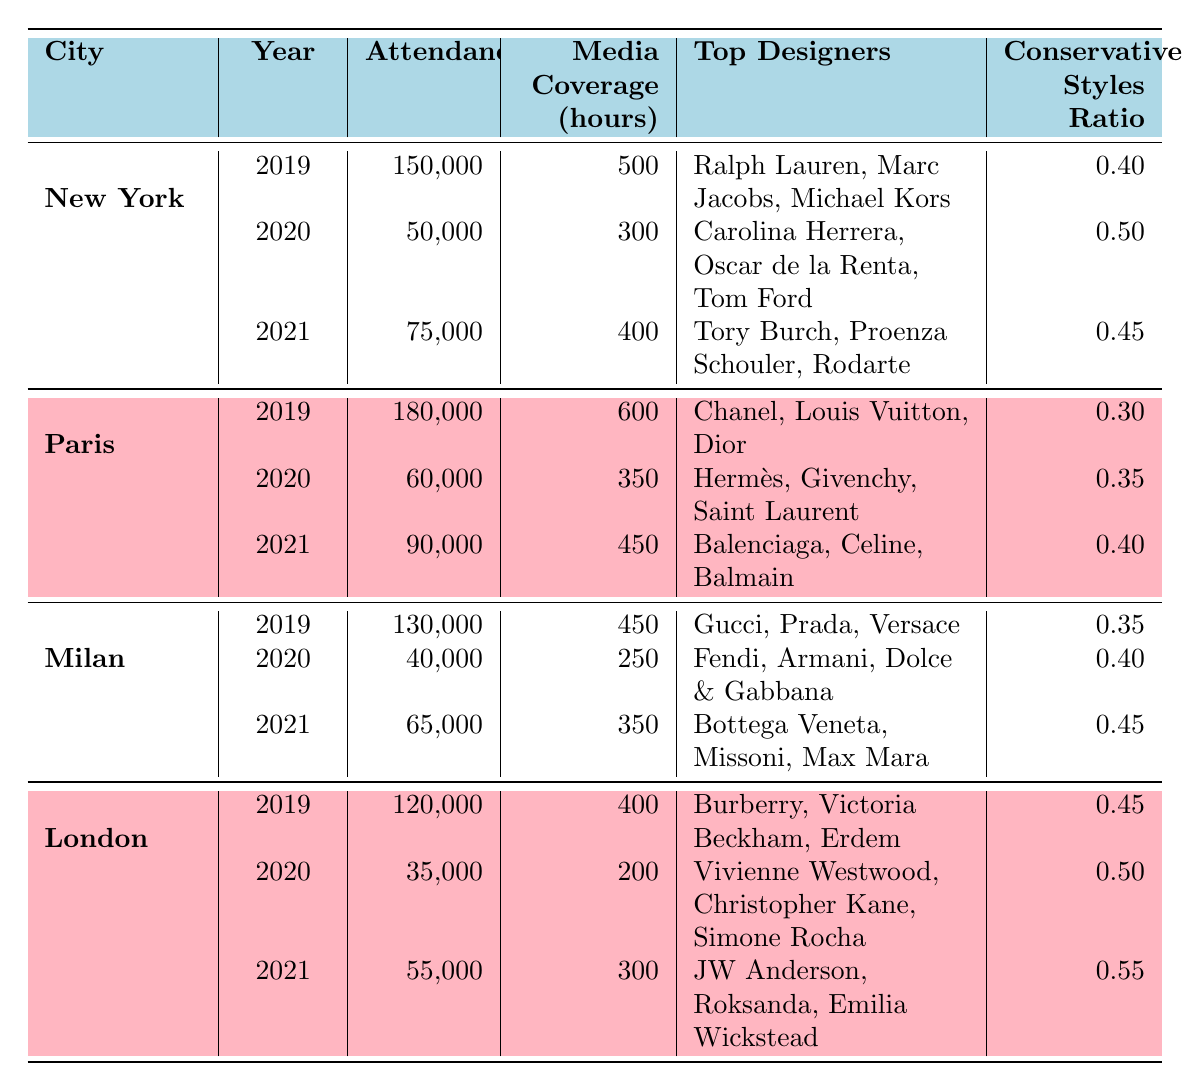What city had the highest attendance in 2019? The table shows the attendance for each city in 2019. New York had 150,000, Paris had 180,000, Milan had 130,000, and London had 120,000. The highest attendance is 180,000 in Paris.
Answer: Paris What was the media coverage in hours for Milan in 2021? For Milan in 2021, the table directly lists the media coverage as 350 hours.
Answer: 350 What was the ratio of conservative styles for London in 2020? The table states that the conservative styles ratio for London in 2020 is 0.50.
Answer: 0.50 Which city had the lowest media coverage in 2020, and what was the amount? The media coverage in 2020 for New York was 300 hours, Paris was 350 hours, Milan was 250 hours, and London was 200 hours. London had the lowest media coverage with 200 hours.
Answer: London, 200 What was the total attendance across all cities in 2019? Adding the attendance values for all cities in 2019 gives: 150,000 (New York) + 180,000 (Paris) + 130,000 (Milan) + 120,000 (London) = 580,000.
Answer: 580,000 Did fashion week attendance increase from 2020 to 2021 in all cities? New York’s attendance changed from 50,000 to 75,000 (increased), Paris's changed from 60,000 to 90,000 (increased), Milan changed from 40,000 to 65,000 (increased), and London changed from 35,000 to 55,000 (increased). Therefore, attendance increased in all cities.
Answer: Yes What is the average conservative styles ratio across all cities in 2021? The conservative styles ratios for 2021 are 0.45 (New York), 0.40 (Paris), 0.45 (Milan), and 0.55 (London). The average is calculated as (0.45 + 0.40 + 0.45 + 0.55) / 4 = 0.4625.
Answer: 0.4625 How many hours of media coverage did Paris have in comparison to New York in 2021? In 2021, Paris had 450 hours and New York had 400 hours. Paris had 50 more hours of media coverage than New York.
Answer: 50 more hours Which city showed an overall increase in attendance from 2019 to 2021? New York's attendance decreased from 150,000 to 75,000, Paris increased from 180,000 to 90,000, Milan decreased from 130,000 to 65,000, and London decreased from 120,000 to 55,000. Therefore, no city showed an increase from 2019 to 2021.
Answer: None 